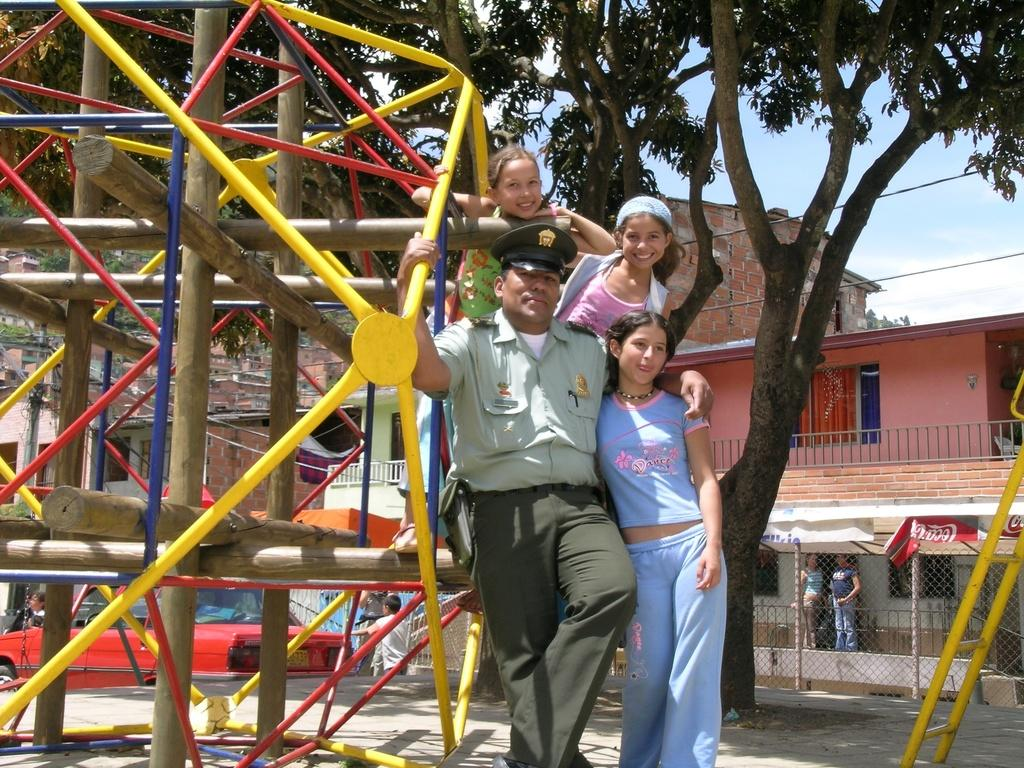What type of natural elements can be seen in the image? There are trees in the image. What type of man-made structures are present in the image? There are buildings in the image. What type of barrier can be seen in the image? There is a fence in the image. Who or what is located in the front of the image? There are people standing in the front of the image. What type of equipment is present in the image that has an ironic or unexpected purpose? There is ironic equipment in the image. What is visible at the top of the image? The sky is visible at the top of the image. What type of nut can be seen growing on the trees in the image? There is no nut growing on the trees in the image; only trees are present. What type of mist is visible in the image? There is no mist visible in the image; only trees, buildings, a fence, people, ironic equipment, and the sky are present. 